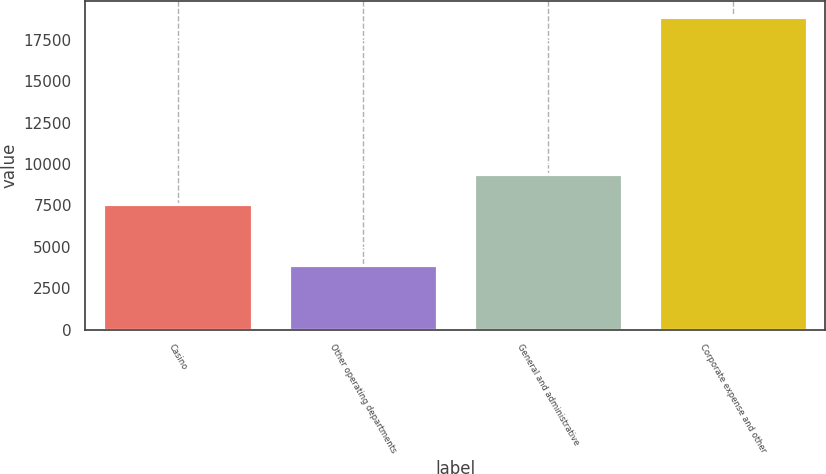<chart> <loc_0><loc_0><loc_500><loc_500><bar_chart><fcel>Casino<fcel>Other operating departments<fcel>General and administrative<fcel>Corporate expense and other<nl><fcel>7552<fcel>3868<fcel>9402<fcel>18885<nl></chart> 